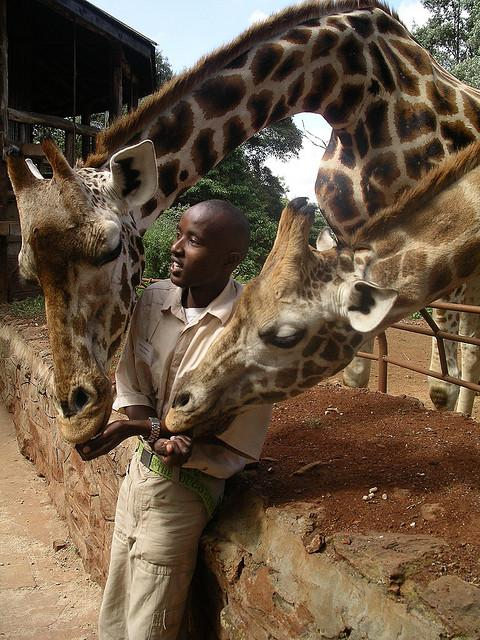What is the man near the giraffes job?

Choices:
A) businessman
B) chef
C) janitor
D) zookeeper zookeeper 